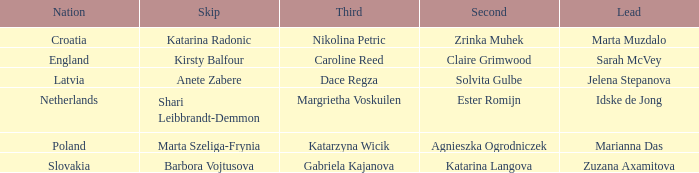Who is the Second with Nikolina Petric as Third? Zrinka Muhek. 